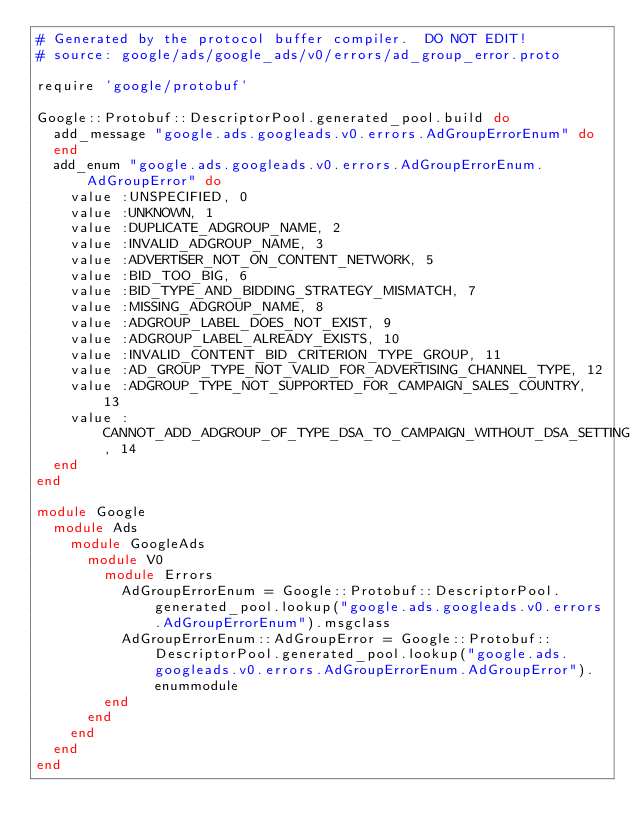<code> <loc_0><loc_0><loc_500><loc_500><_Ruby_># Generated by the protocol buffer compiler.  DO NOT EDIT!
# source: google/ads/google_ads/v0/errors/ad_group_error.proto

require 'google/protobuf'

Google::Protobuf::DescriptorPool.generated_pool.build do
  add_message "google.ads.googleads.v0.errors.AdGroupErrorEnum" do
  end
  add_enum "google.ads.googleads.v0.errors.AdGroupErrorEnum.AdGroupError" do
    value :UNSPECIFIED, 0
    value :UNKNOWN, 1
    value :DUPLICATE_ADGROUP_NAME, 2
    value :INVALID_ADGROUP_NAME, 3
    value :ADVERTISER_NOT_ON_CONTENT_NETWORK, 5
    value :BID_TOO_BIG, 6
    value :BID_TYPE_AND_BIDDING_STRATEGY_MISMATCH, 7
    value :MISSING_ADGROUP_NAME, 8
    value :ADGROUP_LABEL_DOES_NOT_EXIST, 9
    value :ADGROUP_LABEL_ALREADY_EXISTS, 10
    value :INVALID_CONTENT_BID_CRITERION_TYPE_GROUP, 11
    value :AD_GROUP_TYPE_NOT_VALID_FOR_ADVERTISING_CHANNEL_TYPE, 12
    value :ADGROUP_TYPE_NOT_SUPPORTED_FOR_CAMPAIGN_SALES_COUNTRY, 13
    value :CANNOT_ADD_ADGROUP_OF_TYPE_DSA_TO_CAMPAIGN_WITHOUT_DSA_SETTING, 14
  end
end

module Google
  module Ads
    module GoogleAds
      module V0
        module Errors
          AdGroupErrorEnum = Google::Protobuf::DescriptorPool.generated_pool.lookup("google.ads.googleads.v0.errors.AdGroupErrorEnum").msgclass
          AdGroupErrorEnum::AdGroupError = Google::Protobuf::DescriptorPool.generated_pool.lookup("google.ads.googleads.v0.errors.AdGroupErrorEnum.AdGroupError").enummodule
        end
      end
    end
  end
end
</code> 